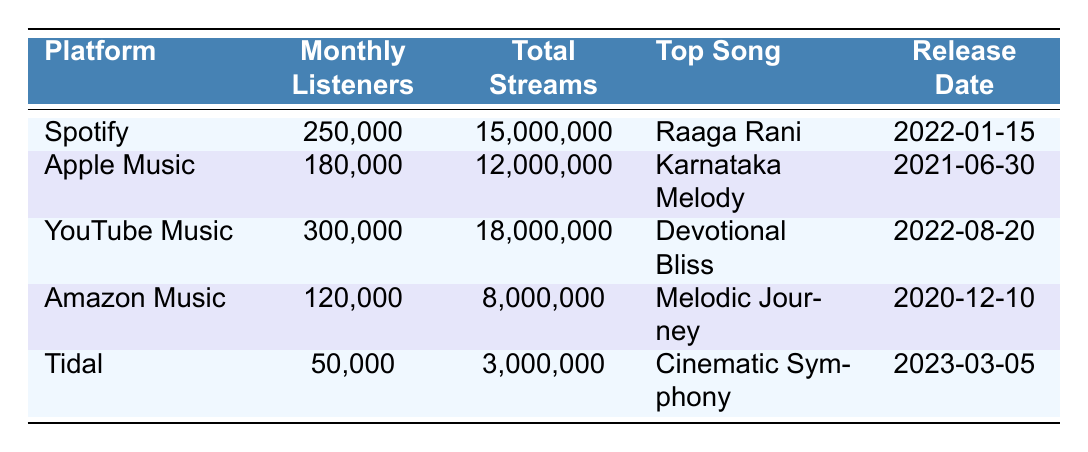What is the top song on YouTube Music? The table states that the top song on YouTube Music is "Devotional Bliss."
Answer: Devotional Bliss Which platform has the highest number of monthly listeners? By looking at the Monthly Listeners column, YouTube Music has the highest count with 300,000 listeners.
Answer: YouTube Music What is the total number of streams for 'Karnataka Melody'? The table indicates that 'Karnataka Melody' on Apple Music has a total of 12,000,000 streams.
Answer: 12,000,000 Is the release date for 'Cinematic Symphony' in 2022? The table shows that 'Cinematic Symphony' was released on March 5, 2023, which means it is not in 2022.
Answer: No What is the average number of monthly listeners across all platforms? Sum the monthly listeners: 250,000 (Spotify) + 180,000 (Apple Music) + 300,000 (YouTube Music) + 120,000 (Amazon Music) + 50,000 (Tidal) = 1,000,000. Since there are 5 platforms, the average is 1,000,000 / 5 = 200,000.
Answer: 200,000 What is the difference in total streams between Spotify and Tidal? Total streams for Spotify is 15,000,000 and for Tidal is 3,000,000. Therefore, the difference is 15,000,000 - 3,000,000 = 12,000,000.
Answer: 12,000,000 Which platform has the least monthly listeners? Tidal has the least monthly listeners with a count of 50,000 as per the table.
Answer: Tidal What percentage of total streams on YouTube Music does 'Devotional Bliss' represent? Total streams on YouTube Music are 18,000,000. The exact percentage cannot be calculated with the data, as it doesn't specify streams for 'Devotional Bliss', so the answer cannot be determined based on the provided table.
Answer: Cannot be determined Which song was released earliest among the listed songs? Comparing the release dates: 'Melodic Journey' (2020-12-10), 'Karnataka Melody' (2021-06-30), 'Raaga Rani' (2022-01-15), 'Devotional Bliss' (2022-08-20), and 'Cinematic Symphony' (2023-03-05), 'Melodic Journey' has the earliest release date.
Answer: Melodic Journey How many total streams do Apple Music and Amazon Music have combined? Total streams for Apple Music is 12,000,000 and for Amazon Music is 8,000,000. When combined, the total streams are 12,000,000 + 8,000,000 = 20,000,000.
Answer: 20,000,000 